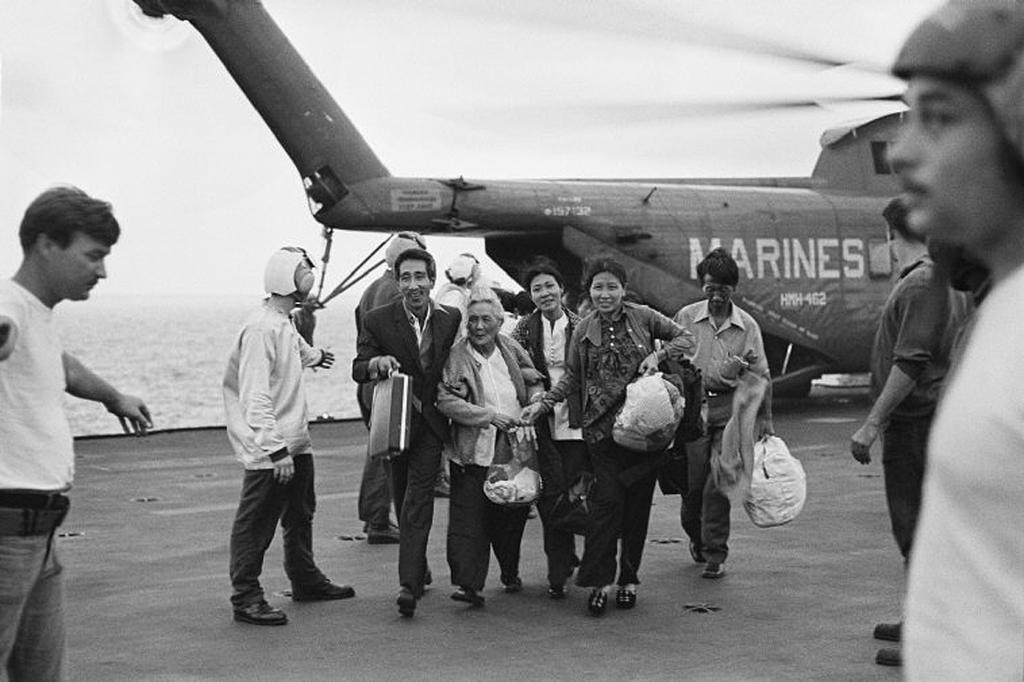In one or two sentences, can you explain what this image depicts? In this image there are some persons standing in the middle of this image. There are four persons holding some objects as we can see in the middle of this image. There is a airplane on the right side of this image. There is a sea on the left side of this image. There is a sky on the top of this image. 